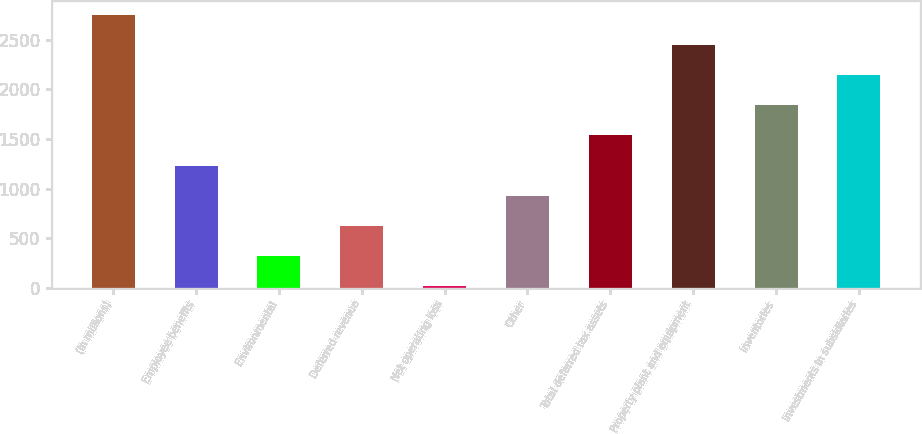<chart> <loc_0><loc_0><loc_500><loc_500><bar_chart><fcel>(In millions)<fcel>Employee benefits<fcel>Environmental<fcel>Deferred revenue<fcel>Net operating loss<fcel>Other<fcel>Total deferred tax assets<fcel>Property plant and equipment<fcel>Inventories<fcel>Investments in subsidiaries<nl><fcel>2756.1<fcel>1231.6<fcel>316.9<fcel>621.8<fcel>12<fcel>926.7<fcel>1536.5<fcel>2451.2<fcel>1841.4<fcel>2146.3<nl></chart> 